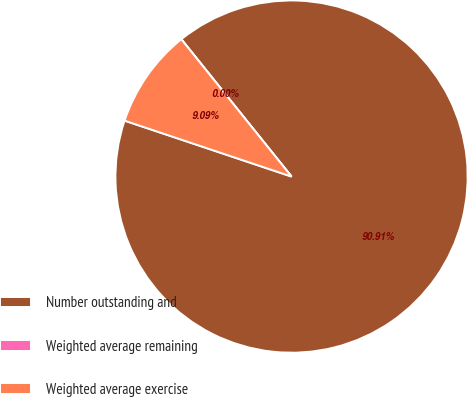<chart> <loc_0><loc_0><loc_500><loc_500><pie_chart><fcel>Number outstanding and<fcel>Weighted average remaining<fcel>Weighted average exercise<nl><fcel>90.91%<fcel>0.0%<fcel>9.09%<nl></chart> 